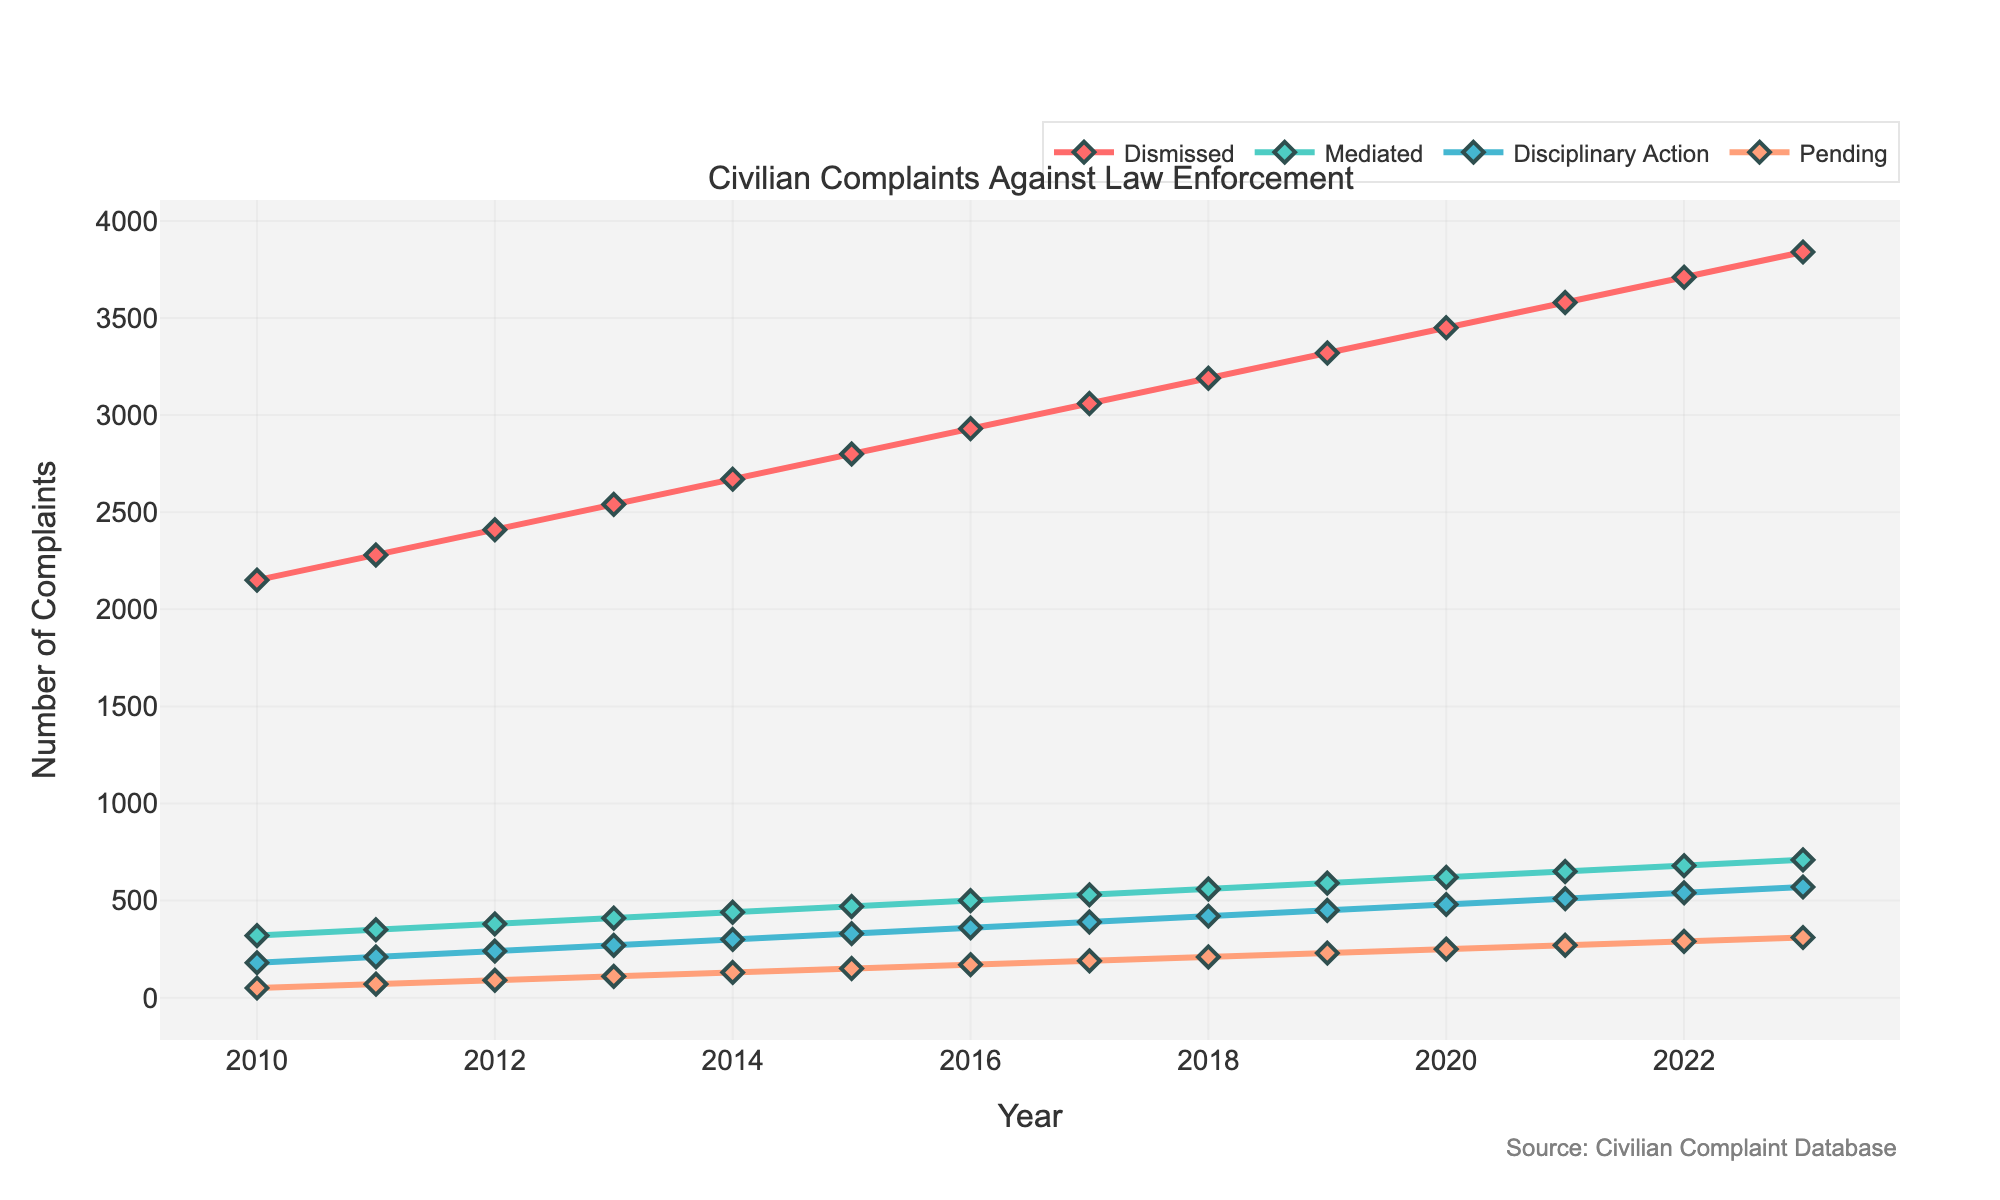What is the trend of complaints that were dismissed from 2010 to 2023? The line for "Dismissed" shows an upward trend from 2010 to 2023, increasing each year.
Answer: Upward Which year had the highest number of complaints leading to disciplinary action? By looking at the "Disciplinary Action" line, the highest point appears in 2023.
Answer: 2023 How many complaints were either mediated or dismissed in 2015? Look at the values for both "Mediated" and "Dismissed" in 2015. Mediated is 470 and Dismissed is 2800. Summing these values: 2800 + 470 = 3270
Answer: 3270 Compare the number of pending complaints in 2012 and 2023. Which year had more, and by how much? The pending complaints in 2012 are 90, and in 2023, they are 310. Subtract the 2012 value from the 2023 value: 310 - 90 = 220. 2023 had more by 220.
Answer: 2023 by 220 Are there any years where the number of mediated complaints exceeds 600? By examining the "Mediated" line, the value exceeds 600 from the year 2020 onwards.
Answer: 2020-2023 What is the average number of dismissed complaints between 2010 and 2013? Sum the dismissed complaints from 2010 (2150), 2011 (2280), 2012 (2410), and 2013 (2540). The sum is 9380. Divide by the 4 years: 9380 / 4 = 2345
Answer: 2345 By what percentage did the number of mediated complaints increase from 2016 to 2023? The mediated complaints in 2016 are 500, and in 2023, they are 710. The increase is 710 - 500 = 210. The percentage increase is (210/500) * 100 = 42%
Answer: 42% Visually, which category of complaint outcomes has the most vibrant color and what does it represent? The category with the most vibrant color is "Pending," represented by a vivid orange line.
Answer: Pending What is the total number of complaints (all categories combined) in 2018? Sum the values of all categories for 2018. Dismissed: 3190, Mediated: 560, Disciplinary Action: 420, Pending: 210. Total = 3190 + 560 + 420 + 210 = 4380
Answer: 4380 Between 2019 and 2020, which resolution outcome had the largest absolute increase in the number of complaints? Calculate the differences for each category between 2019 and 2020. Dismissed increased by 130 (3450 - 3320), Mediated by 30 (620 - 590), Disciplinary Action by 30 (480 - 450), and Pending by 20 (250 - 230). The largest increase is in Dismissed.
Answer: Dismissed 